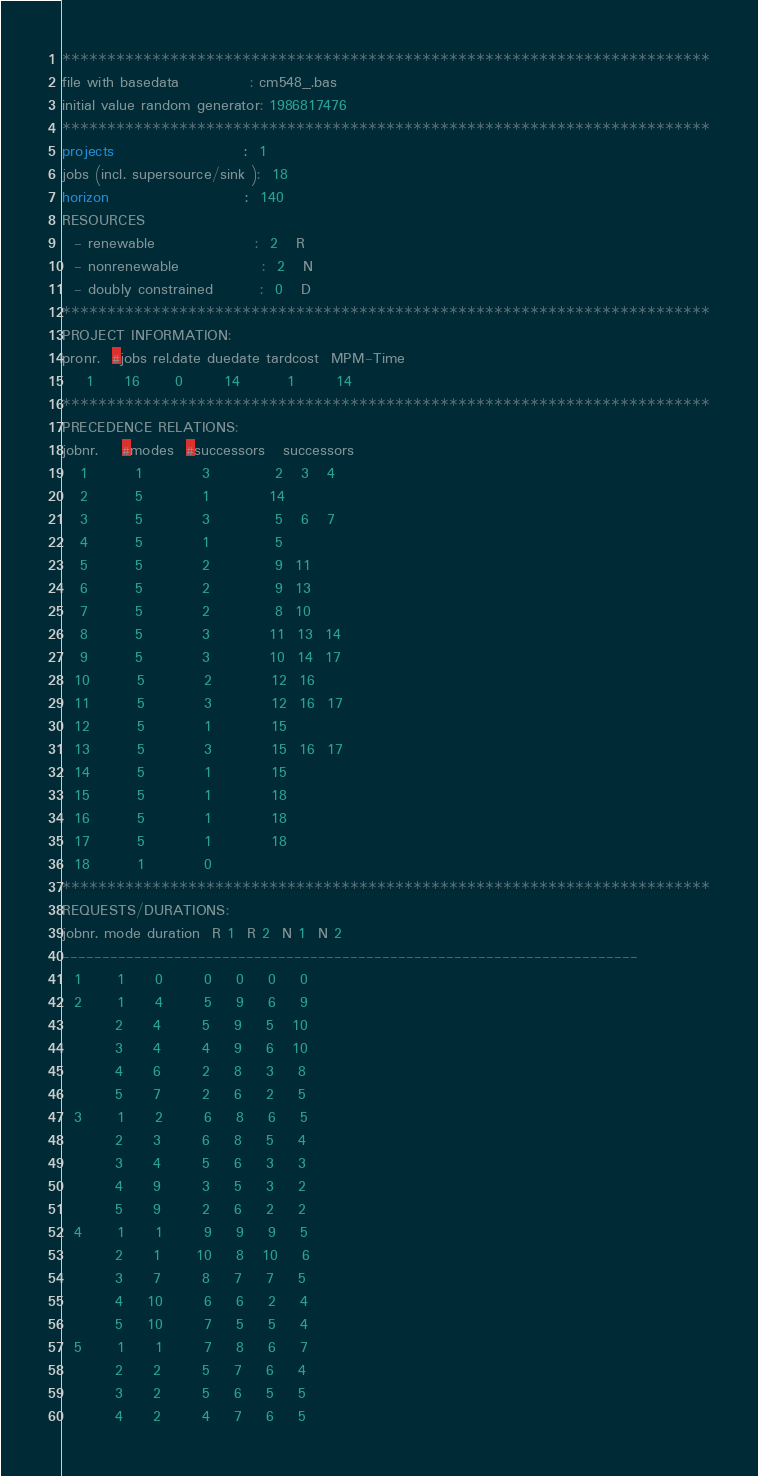Convert code to text. <code><loc_0><loc_0><loc_500><loc_500><_ObjectiveC_>************************************************************************
file with basedata            : cm548_.bas
initial value random generator: 1986817476
************************************************************************
projects                      :  1
jobs (incl. supersource/sink ):  18
horizon                       :  140
RESOURCES
  - renewable                 :  2   R
  - nonrenewable              :  2   N
  - doubly constrained        :  0   D
************************************************************************
PROJECT INFORMATION:
pronr.  #jobs rel.date duedate tardcost  MPM-Time
    1     16      0       14        1       14
************************************************************************
PRECEDENCE RELATIONS:
jobnr.    #modes  #successors   successors
   1        1          3           2   3   4
   2        5          1          14
   3        5          3           5   6   7
   4        5          1           5
   5        5          2           9  11
   6        5          2           9  13
   7        5          2           8  10
   8        5          3          11  13  14
   9        5          3          10  14  17
  10        5          2          12  16
  11        5          3          12  16  17
  12        5          1          15
  13        5          3          15  16  17
  14        5          1          15
  15        5          1          18
  16        5          1          18
  17        5          1          18
  18        1          0        
************************************************************************
REQUESTS/DURATIONS:
jobnr. mode duration  R 1  R 2  N 1  N 2
------------------------------------------------------------------------
  1      1     0       0    0    0    0
  2      1     4       5    9    6    9
         2     4       5    9    5   10
         3     4       4    9    6   10
         4     6       2    8    3    8
         5     7       2    6    2    5
  3      1     2       6    8    6    5
         2     3       6    8    5    4
         3     4       5    6    3    3
         4     9       3    5    3    2
         5     9       2    6    2    2
  4      1     1       9    9    9    5
         2     1      10    8   10    6
         3     7       8    7    7    5
         4    10       6    6    2    4
         5    10       7    5    5    4
  5      1     1       7    8    6    7
         2     2       5    7    6    4
         3     2       5    6    5    5
         4     2       4    7    6    5</code> 